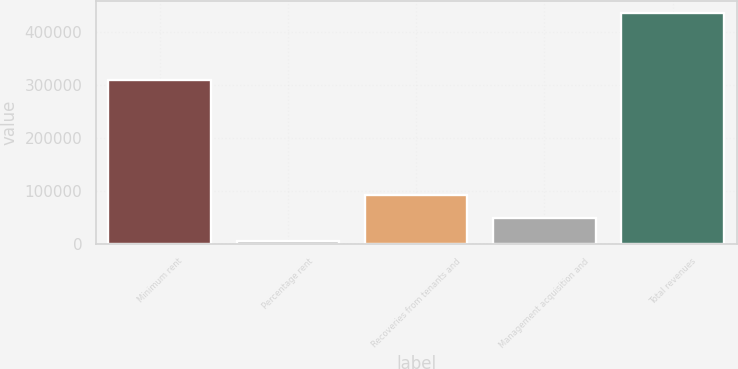Convert chart to OTSL. <chart><loc_0><loc_0><loc_500><loc_500><bar_chart><fcel>Minimum rent<fcel>Percentage rent<fcel>Recoveries from tenants and<fcel>Management acquisition and<fcel>Total revenues<nl><fcel>308720<fcel>4661<fcel>91045.2<fcel>47853.1<fcel>436582<nl></chart> 